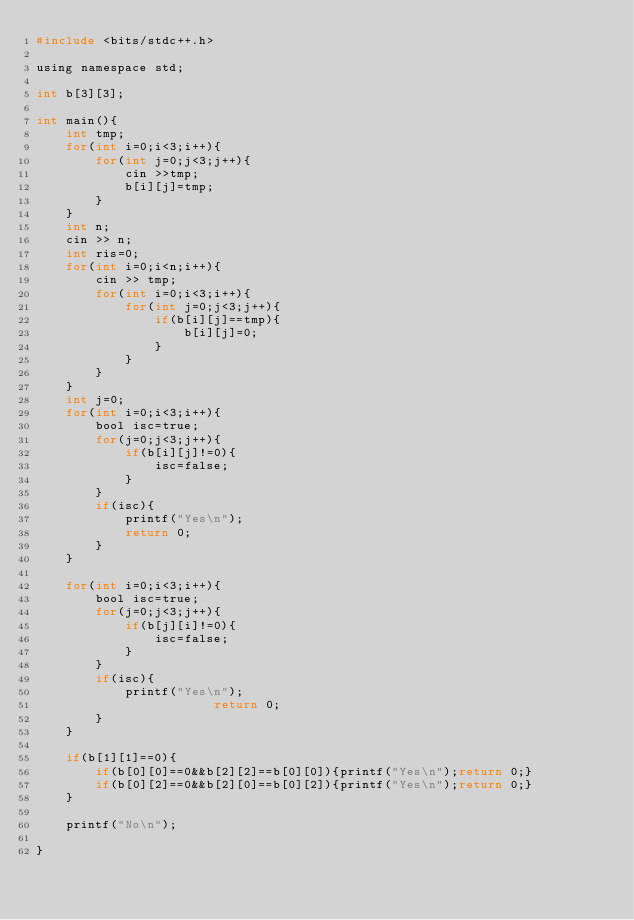<code> <loc_0><loc_0><loc_500><loc_500><_C_>#include <bits/stdc++.h>

using namespace std;

int b[3][3];

int main(){
	int tmp;
	for(int i=0;i<3;i++){
		for(int j=0;j<3;j++){
			cin >>tmp;
			b[i][j]=tmp;
		}			
	}
	int n;
	cin >> n;
	int ris=0;
	for(int i=0;i<n;i++){
		cin >> tmp;
		for(int i=0;i<3;i++){
			for(int j=0;j<3;j++){
				if(b[i][j]==tmp){
					b[i][j]=0;
				}
			}			
		}	
	}
	int j=0;
	for(int i=0;i<3;i++){
		bool isc=true;
		for(j=0;j<3;j++){
			if(b[i][j]!=0){
				isc=false;
			}
		}
		if(isc){
			printf("Yes\n");
			return 0;
		}	
	}	
	
	for(int i=0;i<3;i++){
		bool isc=true;
		for(j=0;j<3;j++){
			if(b[j][i]!=0){
				isc=false;
			}
		}
		if(isc){
			printf("Yes\n");
						return 0;
		}	
	}	

	if(b[1][1]==0){
		if(b[0][0]==0&&b[2][2]==b[0][0]){printf("Yes\n");return 0;}
		if(b[0][2]==0&&b[2][0]==b[0][2]){printf("Yes\n");return 0;}
	}

	printf("No\n");

}</code> 